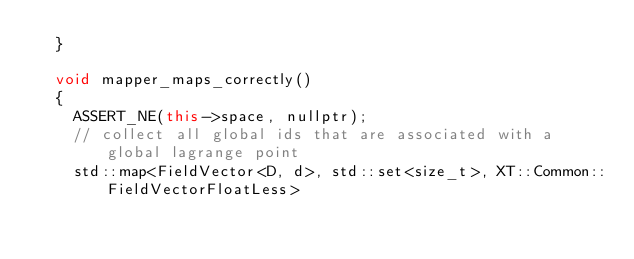Convert code to text. <code><loc_0><loc_0><loc_500><loc_500><_C++_>  }

  void mapper_maps_correctly()
  {
    ASSERT_NE(this->space, nullptr);
    // collect all global ids that are associated with a global lagrange point
    std::map<FieldVector<D, d>, std::set<size_t>, XT::Common::FieldVectorFloatLess></code> 